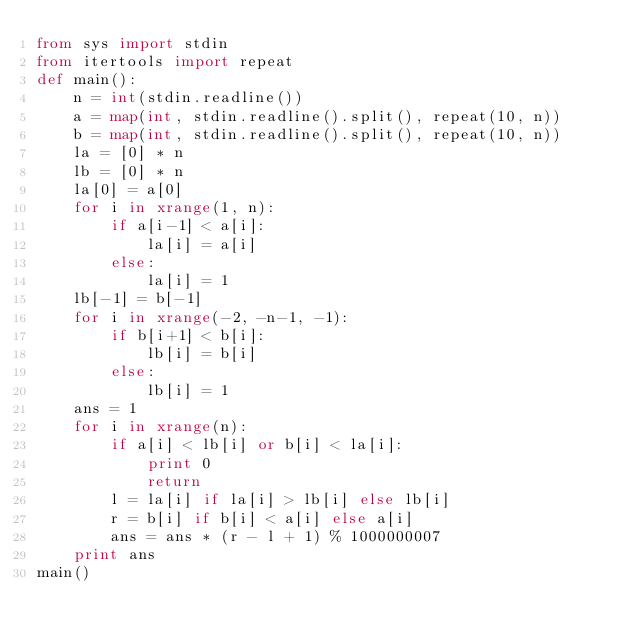Convert code to text. <code><loc_0><loc_0><loc_500><loc_500><_Python_>from sys import stdin
from itertools import repeat
def main():
    n = int(stdin.readline())
    a = map(int, stdin.readline().split(), repeat(10, n))
    b = map(int, stdin.readline().split(), repeat(10, n))
    la = [0] * n
    lb = [0] * n
    la[0] = a[0]
    for i in xrange(1, n):
        if a[i-1] < a[i]:
            la[i] = a[i]
        else:
            la[i] = 1
    lb[-1] = b[-1]
    for i in xrange(-2, -n-1, -1):
        if b[i+1] < b[i]:
            lb[i] = b[i]
        else:
            lb[i] = 1
    ans = 1
    for i in xrange(n):
        if a[i] < lb[i] or b[i] < la[i]:
            print 0
            return
        l = la[i] if la[i] > lb[i] else lb[i]
        r = b[i] if b[i] < a[i] else a[i]
        ans = ans * (r - l + 1) % 1000000007
    print ans
main()
</code> 